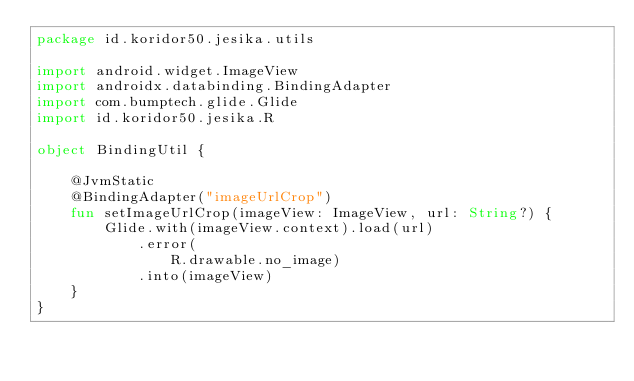Convert code to text. <code><loc_0><loc_0><loc_500><loc_500><_Kotlin_>package id.koridor50.jesika.utils

import android.widget.ImageView
import androidx.databinding.BindingAdapter
import com.bumptech.glide.Glide
import id.koridor50.jesika.R

object BindingUtil {

    @JvmStatic
    @BindingAdapter("imageUrlCrop")
    fun setImageUrlCrop(imageView: ImageView, url: String?) {
        Glide.with(imageView.context).load(url)
            .error(
                R.drawable.no_image)
            .into(imageView)
    }
}</code> 